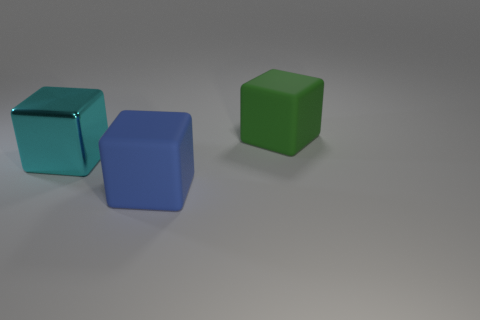Subtract all matte blocks. How many blocks are left? 1 Add 3 tiny brown objects. How many objects exist? 6 Subtract all blue cubes. How many cubes are left? 2 Subtract 2 blocks. How many blocks are left? 1 Add 1 blue blocks. How many blue blocks are left? 2 Add 3 large gray shiny cubes. How many large gray shiny cubes exist? 3 Subtract 0 gray spheres. How many objects are left? 3 Subtract all brown cubes. Subtract all brown balls. How many cubes are left? 3 Subtract all large objects. Subtract all small brown things. How many objects are left? 0 